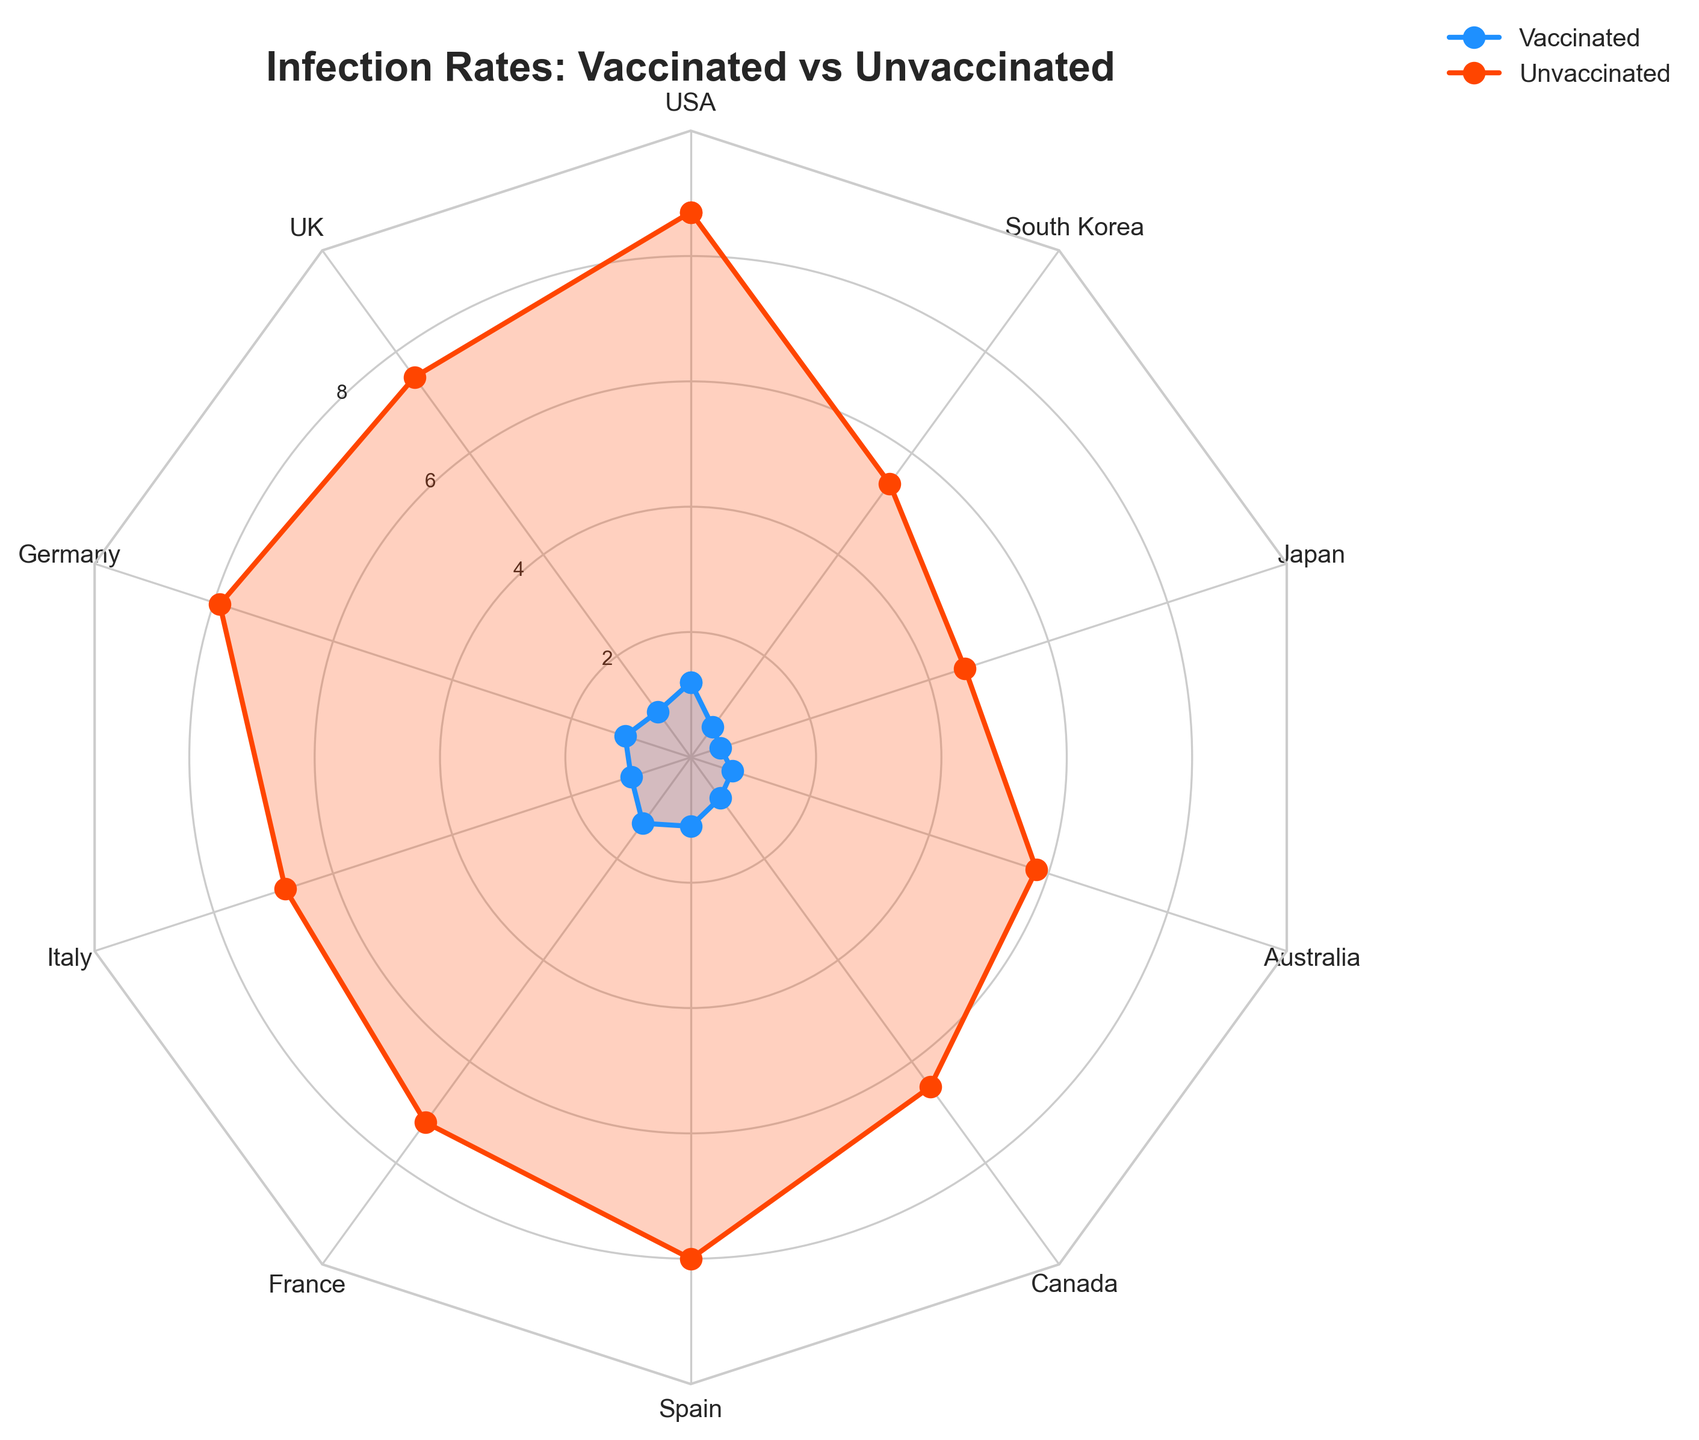what is the title of the plot? The title of the plot can be found at the top of the chart, it is usually in a larger and bold font.
Answer: Infection Rates: Vaccinated vs Unvaccinated what is the infection rate for vaccinated individuals in the UK? Look at the radar chart, follow the axis labeled "UK" and check the blue line for the infection rate of vaccinated individuals.
Answer: 0.9 which country has the lowest infection rate for vaccinated individuals? Compare all the blue lines representing vaccinated individuals, and identify the country at the lowest point.
Answer: Japan which category has the greatest difference in infection rates between vaccinated and unvaccinated individuals? Calculate the difference for each country by subtracting the infection rate of vaccinated from the unvaccinated. Identify which country has the largest resulting value.
Answer: USA what is the average infection rate for unvaccinated individuals? Sum all the infection rates of unvaccinated individuals and divide by the number of data points (10).
Answer: 6.86 how does the infection rate for vaccinated individuals in France compare to those in Italy? Check the blue line values on the radar chart for France and Italy, and compare the two values.
Answer: France has a higher infection rate what is the range of infection rates for vaccinated individuals? Identify the highest and lowest points of the blue lines, then subtract the lowest from the highest.
Answer: 0.8 how many different categories are compared in this chart? Count the number of labels provided around the radar chart.
Answer: 10 if the infection rate for vaccinated individuals in Canada increased by 0.5, would it surpass the rate of any other country? Add 0.5 to Canada's current infection rate (0.8) and compare the new rate (1.3) to the rates of other vaccinated individuals.
Answer: Yes, Spain 